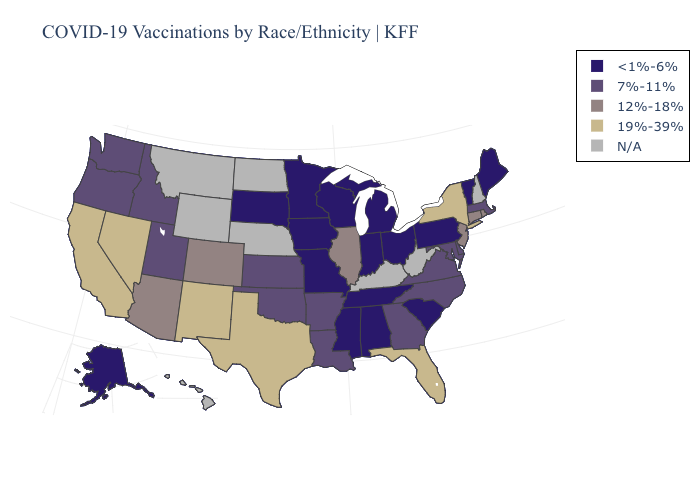What is the value of Rhode Island?
Write a very short answer. 12%-18%. Does the map have missing data?
Quick response, please. Yes. What is the highest value in the South ?
Give a very brief answer. 19%-39%. Among the states that border New Mexico , which have the lowest value?
Concise answer only. Oklahoma, Utah. Does Georgia have the lowest value in the USA?
Keep it brief. No. What is the value of Illinois?
Give a very brief answer. 12%-18%. Among the states that border Mississippi , does Tennessee have the highest value?
Give a very brief answer. No. What is the value of Delaware?
Be succinct. 7%-11%. Among the states that border Arkansas , which have the highest value?
Write a very short answer. Texas. What is the highest value in states that border Pennsylvania?
Quick response, please. 19%-39%. What is the value of Nevada?
Write a very short answer. 19%-39%. Does the map have missing data?
Keep it brief. Yes. Name the states that have a value in the range <1%-6%?
Answer briefly. Alabama, Alaska, Indiana, Iowa, Maine, Michigan, Minnesota, Mississippi, Missouri, Ohio, Pennsylvania, South Carolina, South Dakota, Tennessee, Vermont, Wisconsin. Among the states that border Washington , which have the highest value?
Answer briefly. Idaho, Oregon. Which states have the highest value in the USA?
Concise answer only. California, Florida, Nevada, New Mexico, New York, Texas. 